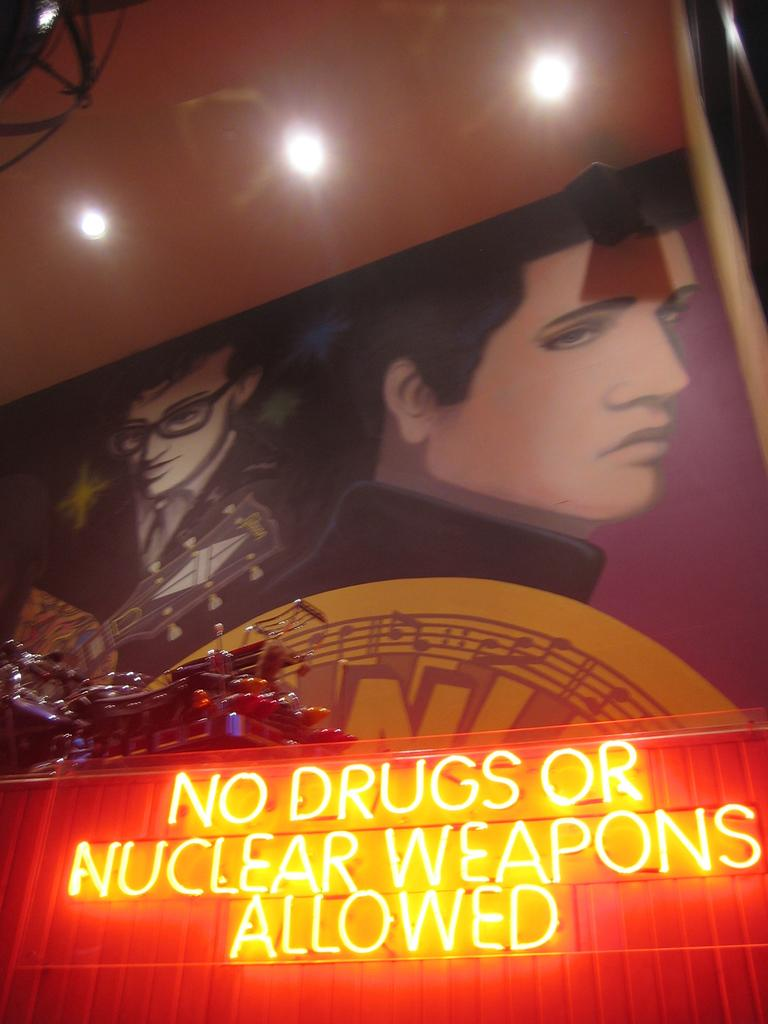What type of poster is in the image? There is a man poster in the image. Is there any text or information visible in the image? Yes, there is a naming board in the front bottom side of the image. What can be seen on the ceiling of the image? There are three spotlights on the top ceiling of the image. What type of juice is being served in the image? There is no juice present in the image. Are there any balloons or a farmer in the image? No, there are no balloons or a farmer in the image. 